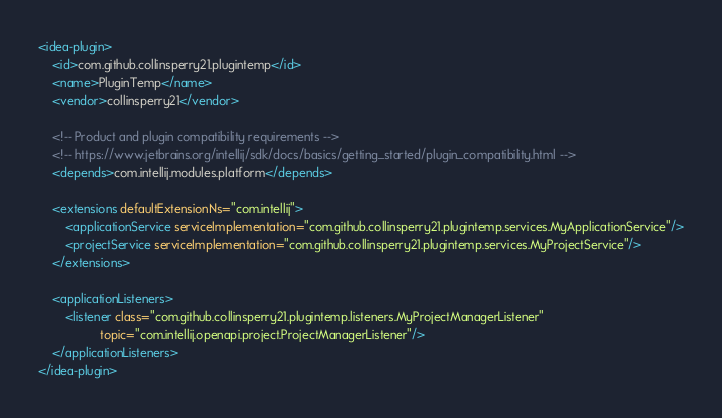Convert code to text. <code><loc_0><loc_0><loc_500><loc_500><_XML_><idea-plugin>
    <id>com.github.collinsperry21.plugintemp</id>
    <name>PluginTemp</name>
    <vendor>collinsperry21</vendor>

    <!-- Product and plugin compatibility requirements -->
    <!-- https://www.jetbrains.org/intellij/sdk/docs/basics/getting_started/plugin_compatibility.html -->
    <depends>com.intellij.modules.platform</depends>

    <extensions defaultExtensionNs="com.intellij">
        <applicationService serviceImplementation="com.github.collinsperry21.plugintemp.services.MyApplicationService"/>
        <projectService serviceImplementation="com.github.collinsperry21.plugintemp.services.MyProjectService"/>
    </extensions>

    <applicationListeners>
        <listener class="com.github.collinsperry21.plugintemp.listeners.MyProjectManagerListener"
                  topic="com.intellij.openapi.project.ProjectManagerListener"/>
    </applicationListeners>
</idea-plugin>
</code> 